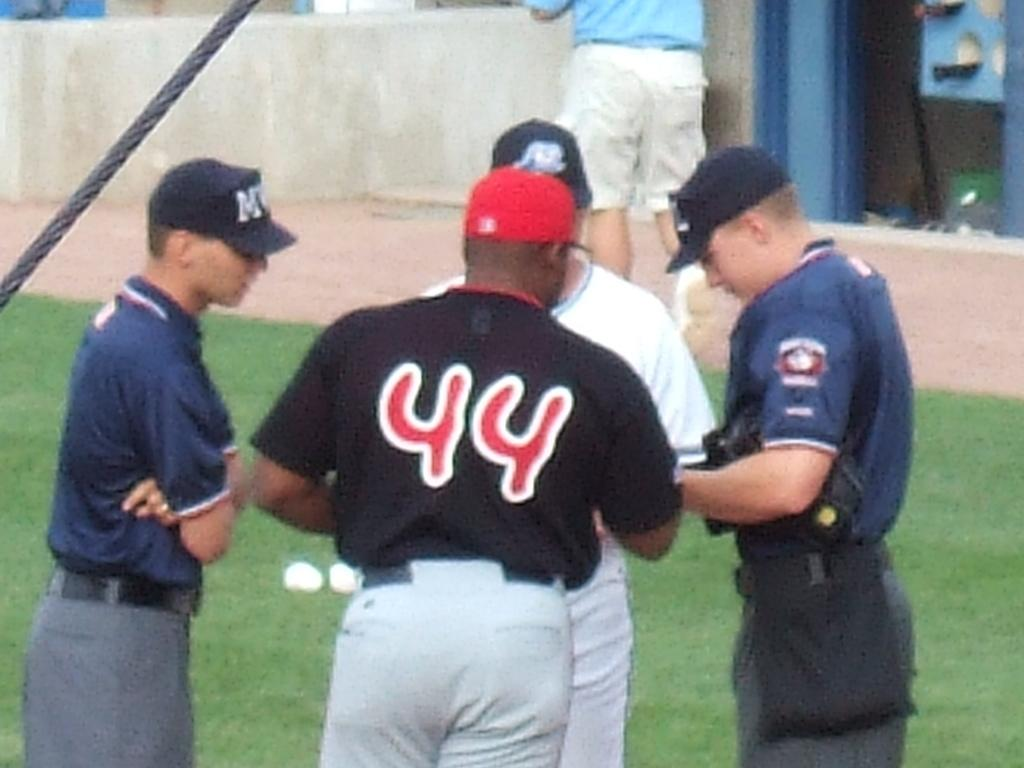<image>
Describe the image concisely. Men are in a huddle and the man with the red cap has a shirt reading 44. 